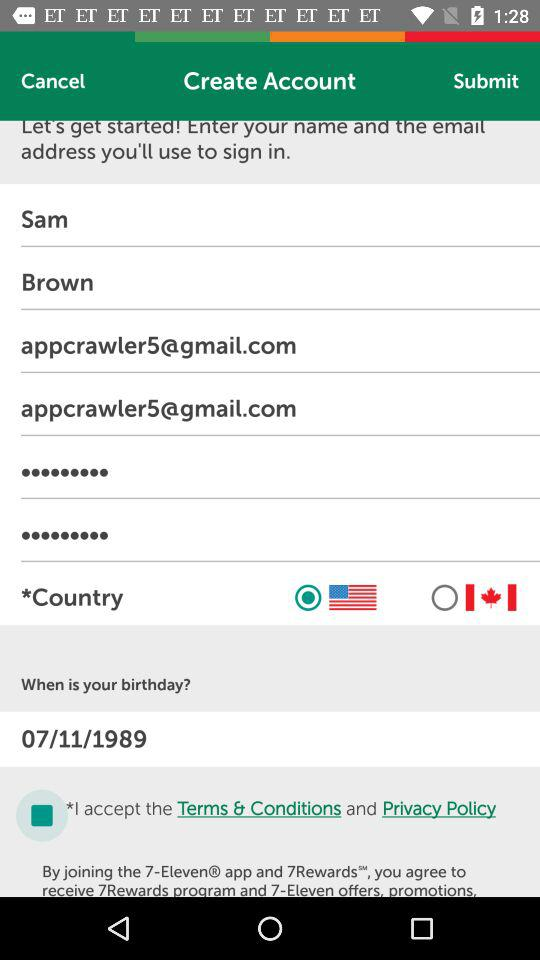What is the Email address? The email address is appcrawler5@gmail.com. 